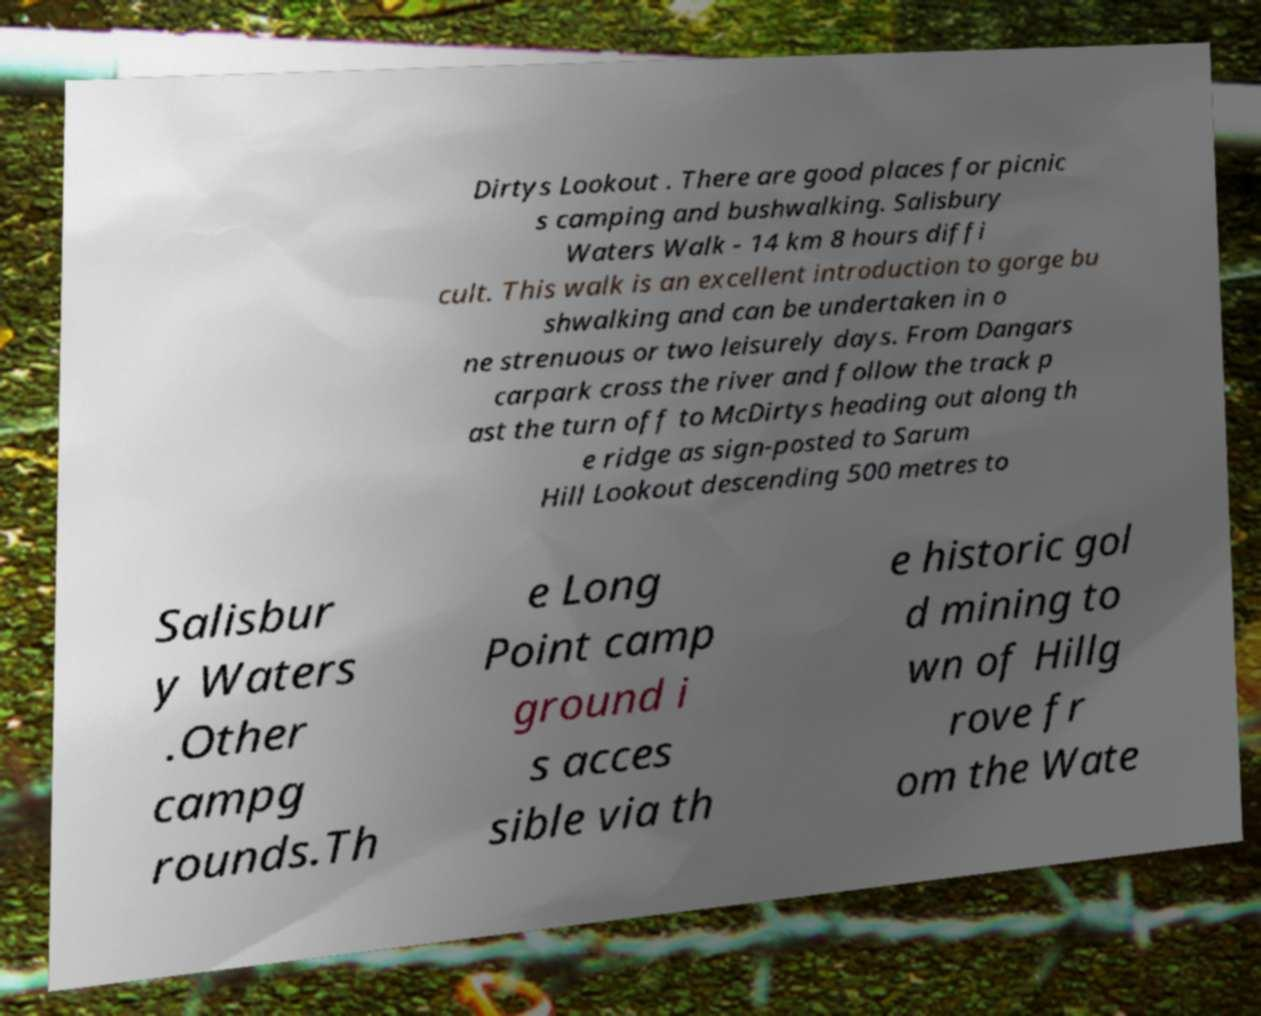Could you assist in decoding the text presented in this image and type it out clearly? Dirtys Lookout . There are good places for picnic s camping and bushwalking. Salisbury Waters Walk - 14 km 8 hours diffi cult. This walk is an excellent introduction to gorge bu shwalking and can be undertaken in o ne strenuous or two leisurely days. From Dangars carpark cross the river and follow the track p ast the turn off to McDirtys heading out along th e ridge as sign-posted to Sarum Hill Lookout descending 500 metres to Salisbur y Waters .Other campg rounds.Th e Long Point camp ground i s acces sible via th e historic gol d mining to wn of Hillg rove fr om the Wate 